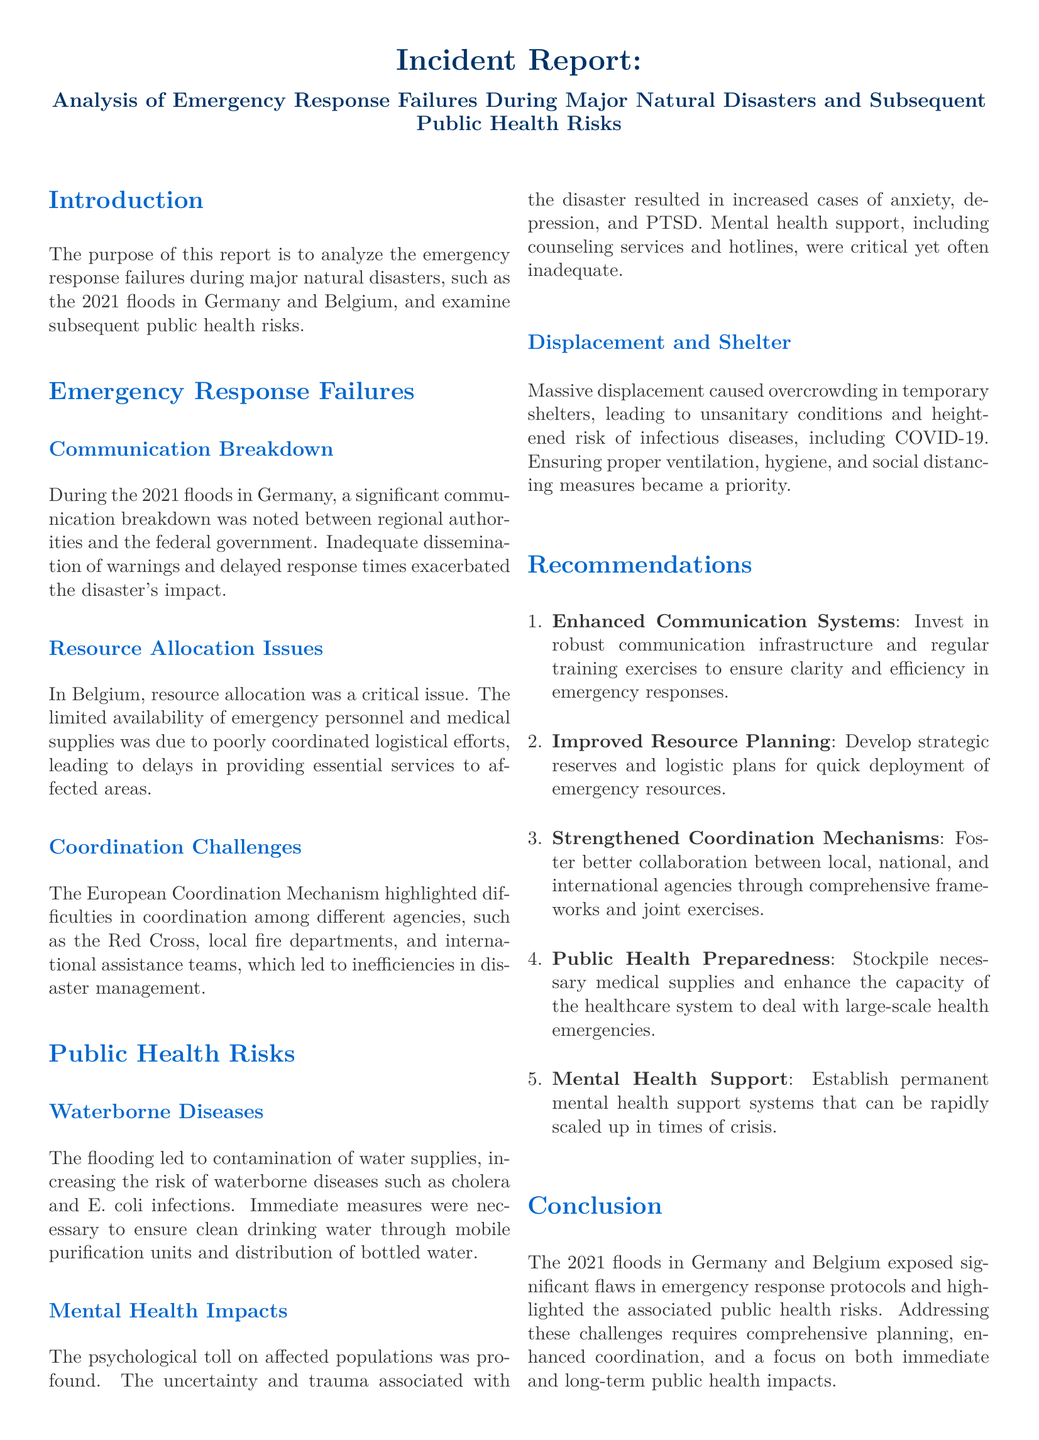what major natural disaster is analyzed in this report? The report focuses on the 2021 floods in Germany and Belgium as the major natural disaster.
Answer: 2021 floods in Germany and Belgium what are two specific public health risks mentioned? The document lists waterborne diseases and mental health impacts as specific public health risks resulting from the disaster.
Answer: waterborne diseases, mental health impacts what recommendation is given for communication systems? The report recommends investing in robust communication infrastructure and regular training exercises to improve emergency responses.
Answer: Enhanced Communication Systems which organization was highlighted for coordination challenges? The European Coordination Mechanism is mentioned as experiencing coordination challenges during the disaster response.
Answer: European Coordination Mechanism what type of diseases increased due to contaminated water supplies? The report indicates that waterborne diseases such as cholera and E. coli infections increased due to contaminated water supplies.
Answer: cholera and E. coli infections how many recommendations are provided in the report? The report includes a total of five recommendations aimed at improving emergency responses and public health preparedness.
Answer: 5 what mental health conditions were noted as increasing in the affected populations? The document states that the uncertainty and trauma resulted in increased cases of anxiety, depression, and PTSD among affected populations.
Answer: anxiety, depression, and PTSD what type of planning is emphasized for emergency resources? The report emphasizes improved resource planning, mentioning the development of strategic reserves and logistic plans.
Answer: Improved Resource Planning 